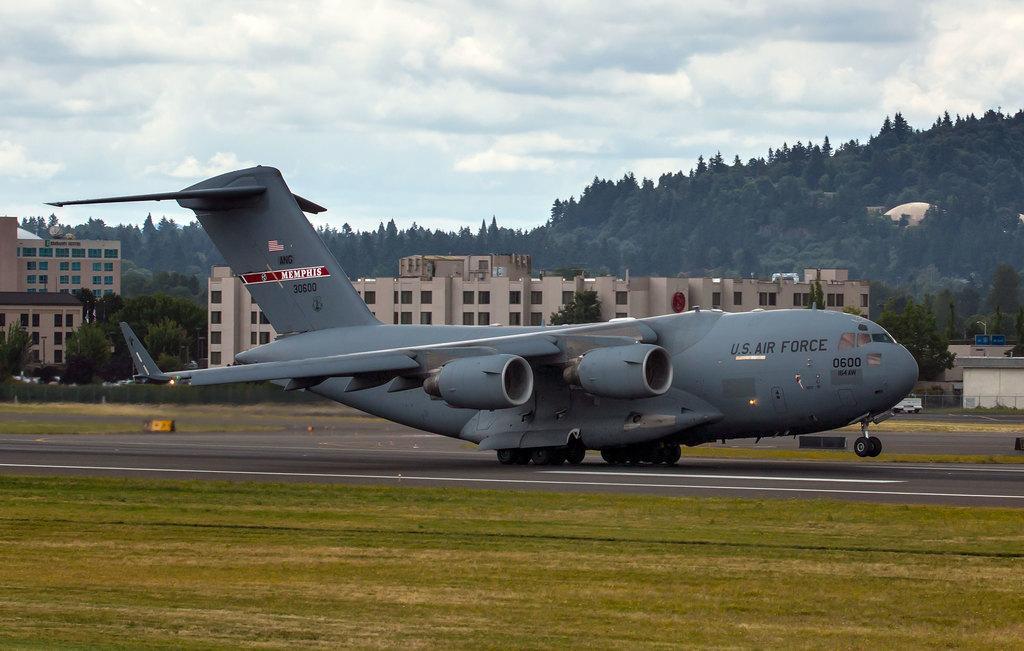Describe this image in one or two sentences. This is an outside view. In the middle of the image there is an aeroplane on the road facing towards the right side. On both sides of the road, I can see the grass. In the background there are many trees and buildings. At the top of the image I can see the sky and clouds. 